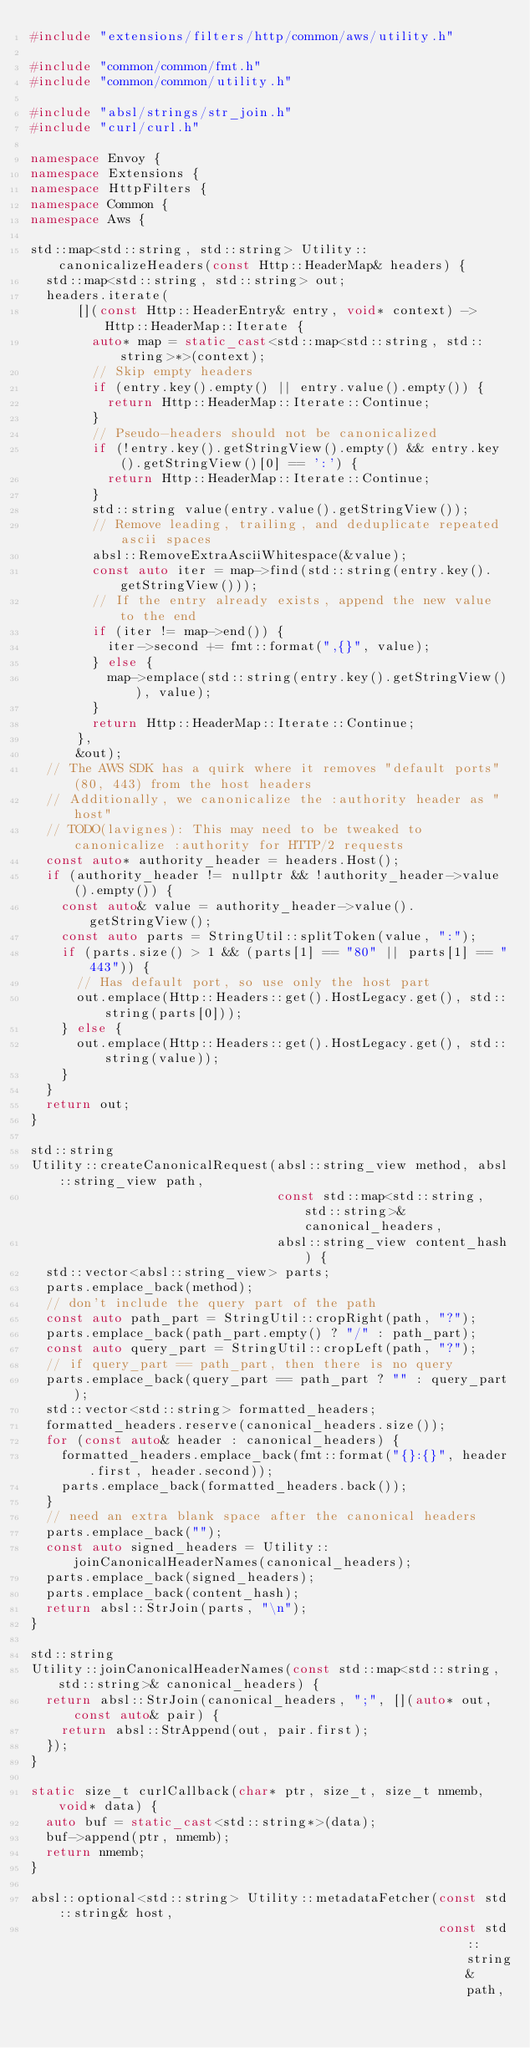<code> <loc_0><loc_0><loc_500><loc_500><_C++_>#include "extensions/filters/http/common/aws/utility.h"

#include "common/common/fmt.h"
#include "common/common/utility.h"

#include "absl/strings/str_join.h"
#include "curl/curl.h"

namespace Envoy {
namespace Extensions {
namespace HttpFilters {
namespace Common {
namespace Aws {

std::map<std::string, std::string> Utility::canonicalizeHeaders(const Http::HeaderMap& headers) {
  std::map<std::string, std::string> out;
  headers.iterate(
      [](const Http::HeaderEntry& entry, void* context) -> Http::HeaderMap::Iterate {
        auto* map = static_cast<std::map<std::string, std::string>*>(context);
        // Skip empty headers
        if (entry.key().empty() || entry.value().empty()) {
          return Http::HeaderMap::Iterate::Continue;
        }
        // Pseudo-headers should not be canonicalized
        if (!entry.key().getStringView().empty() && entry.key().getStringView()[0] == ':') {
          return Http::HeaderMap::Iterate::Continue;
        }
        std::string value(entry.value().getStringView());
        // Remove leading, trailing, and deduplicate repeated ascii spaces
        absl::RemoveExtraAsciiWhitespace(&value);
        const auto iter = map->find(std::string(entry.key().getStringView()));
        // If the entry already exists, append the new value to the end
        if (iter != map->end()) {
          iter->second += fmt::format(",{}", value);
        } else {
          map->emplace(std::string(entry.key().getStringView()), value);
        }
        return Http::HeaderMap::Iterate::Continue;
      },
      &out);
  // The AWS SDK has a quirk where it removes "default ports" (80, 443) from the host headers
  // Additionally, we canonicalize the :authority header as "host"
  // TODO(lavignes): This may need to be tweaked to canonicalize :authority for HTTP/2 requests
  const auto* authority_header = headers.Host();
  if (authority_header != nullptr && !authority_header->value().empty()) {
    const auto& value = authority_header->value().getStringView();
    const auto parts = StringUtil::splitToken(value, ":");
    if (parts.size() > 1 && (parts[1] == "80" || parts[1] == "443")) {
      // Has default port, so use only the host part
      out.emplace(Http::Headers::get().HostLegacy.get(), std::string(parts[0]));
    } else {
      out.emplace(Http::Headers::get().HostLegacy.get(), std::string(value));
    }
  }
  return out;
}

std::string
Utility::createCanonicalRequest(absl::string_view method, absl::string_view path,
                                const std::map<std::string, std::string>& canonical_headers,
                                absl::string_view content_hash) {
  std::vector<absl::string_view> parts;
  parts.emplace_back(method);
  // don't include the query part of the path
  const auto path_part = StringUtil::cropRight(path, "?");
  parts.emplace_back(path_part.empty() ? "/" : path_part);
  const auto query_part = StringUtil::cropLeft(path, "?");
  // if query_part == path_part, then there is no query
  parts.emplace_back(query_part == path_part ? "" : query_part);
  std::vector<std::string> formatted_headers;
  formatted_headers.reserve(canonical_headers.size());
  for (const auto& header : canonical_headers) {
    formatted_headers.emplace_back(fmt::format("{}:{}", header.first, header.second));
    parts.emplace_back(formatted_headers.back());
  }
  // need an extra blank space after the canonical headers
  parts.emplace_back("");
  const auto signed_headers = Utility::joinCanonicalHeaderNames(canonical_headers);
  parts.emplace_back(signed_headers);
  parts.emplace_back(content_hash);
  return absl::StrJoin(parts, "\n");
}

std::string
Utility::joinCanonicalHeaderNames(const std::map<std::string, std::string>& canonical_headers) {
  return absl::StrJoin(canonical_headers, ";", [](auto* out, const auto& pair) {
    return absl::StrAppend(out, pair.first);
  });
}

static size_t curlCallback(char* ptr, size_t, size_t nmemb, void* data) {
  auto buf = static_cast<std::string*>(data);
  buf->append(ptr, nmemb);
  return nmemb;
}

absl::optional<std::string> Utility::metadataFetcher(const std::string& host,
                                                     const std::string& path,</code> 